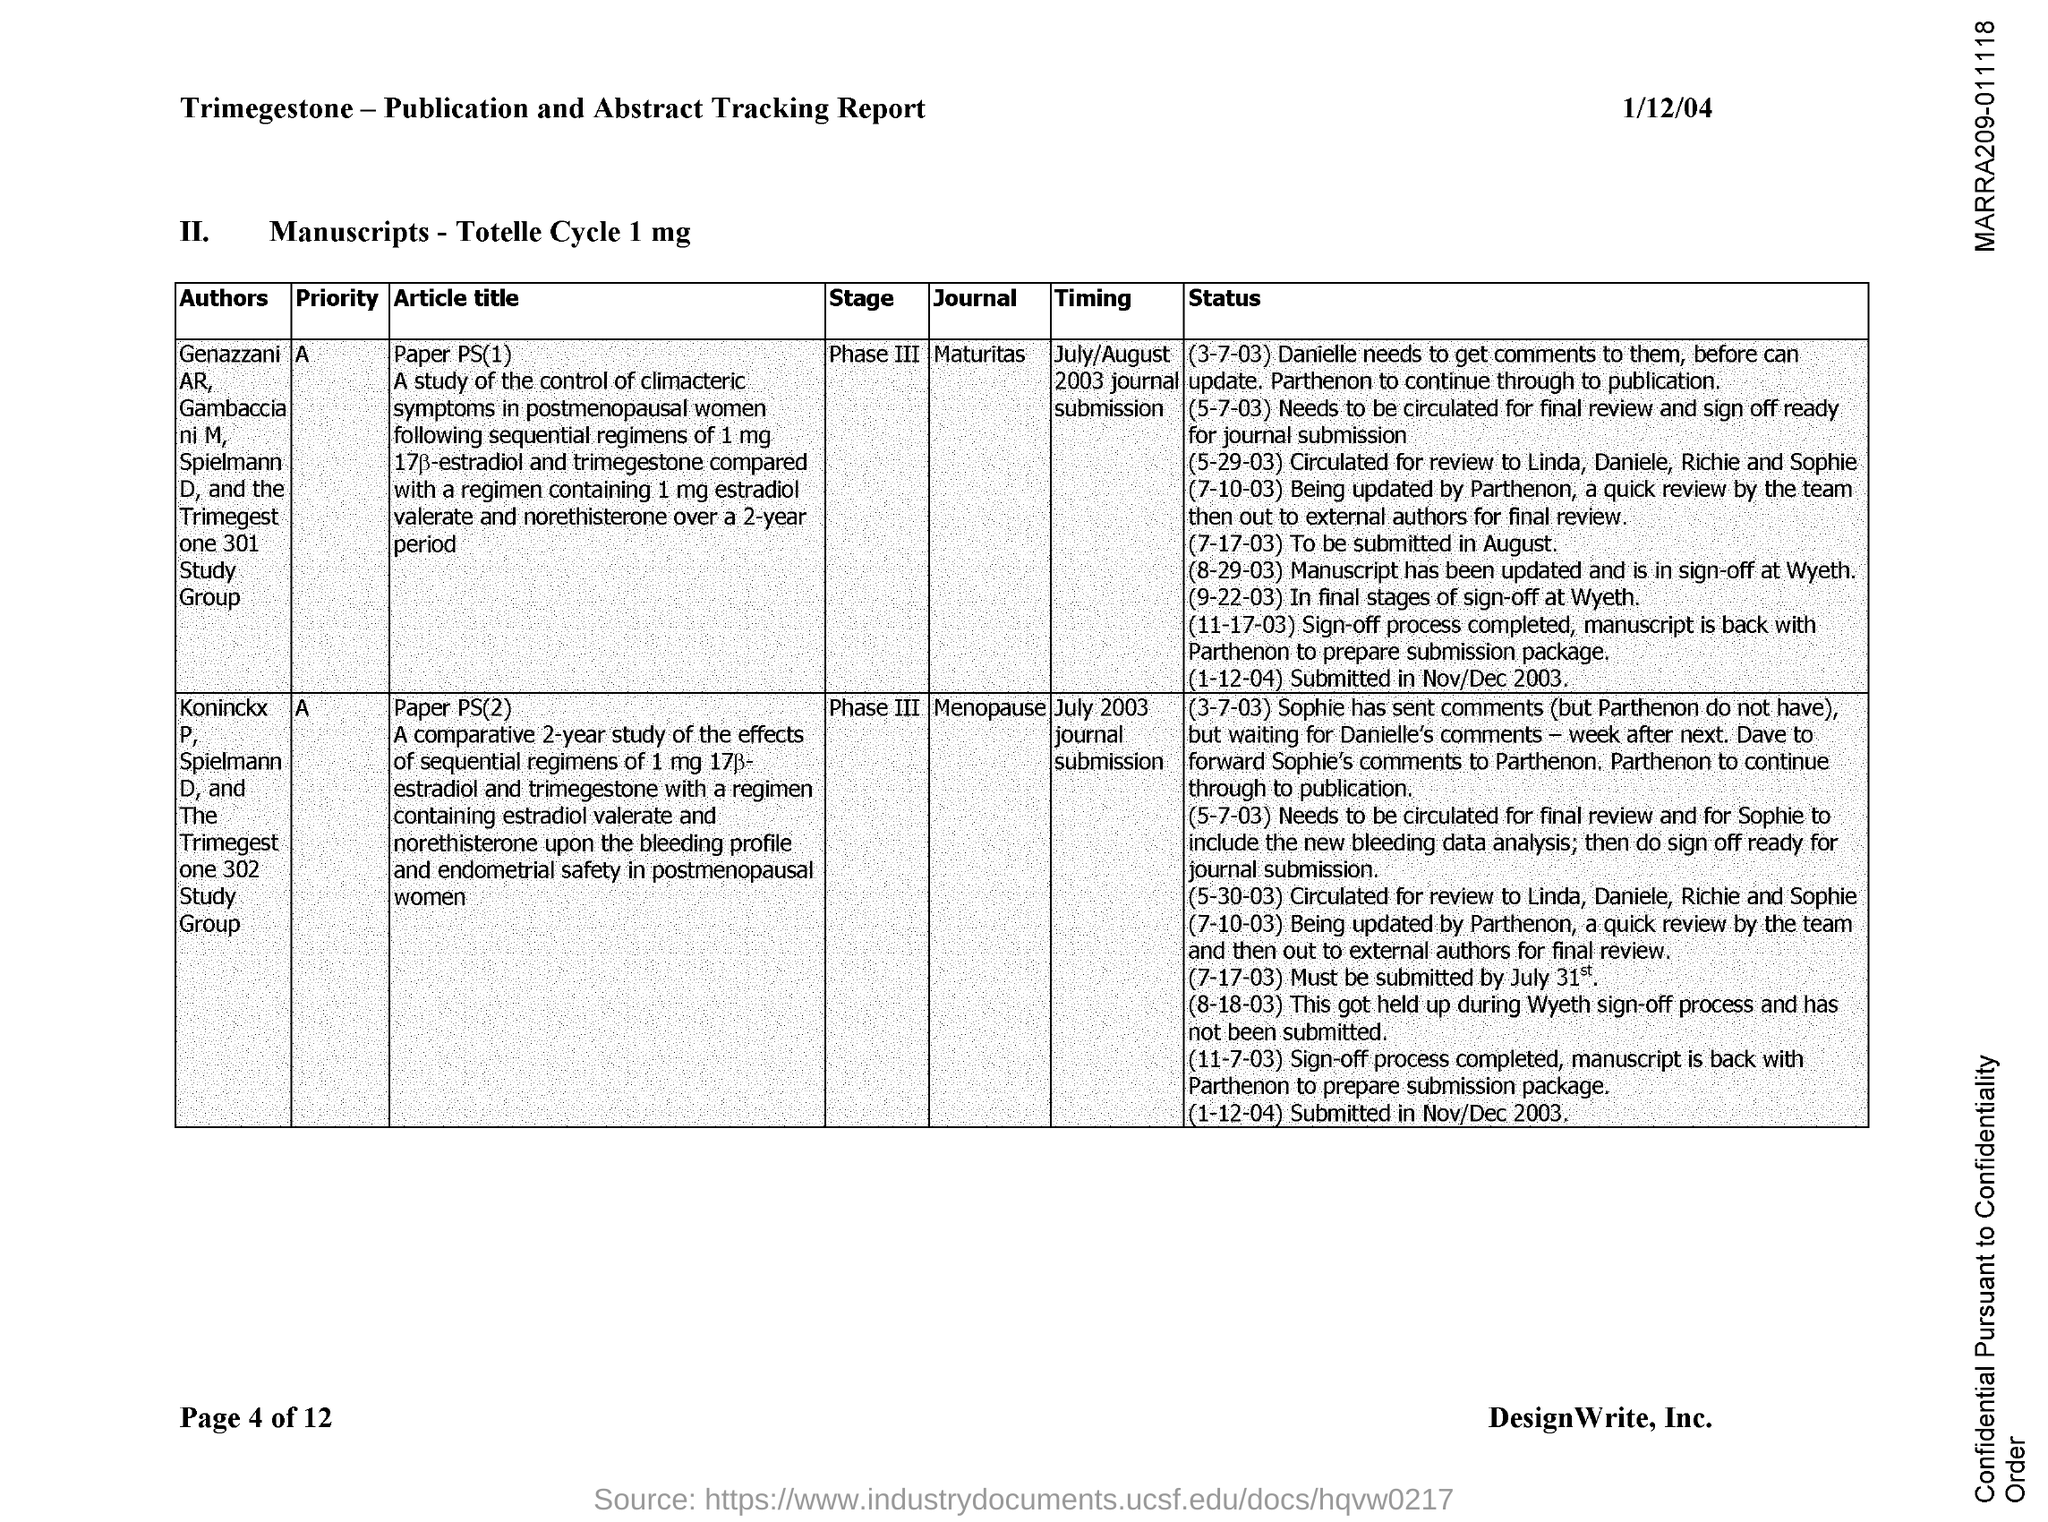Identify some key points in this picture. The date on the document is January 12th, 2004. 